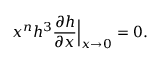Convert formula to latex. <formula><loc_0><loc_0><loc_500><loc_500>x ^ { n } h ^ { 3 } \frac { \partial h } { \partial x } \Big | _ { x \rightarrow 0 } = 0 .</formula> 